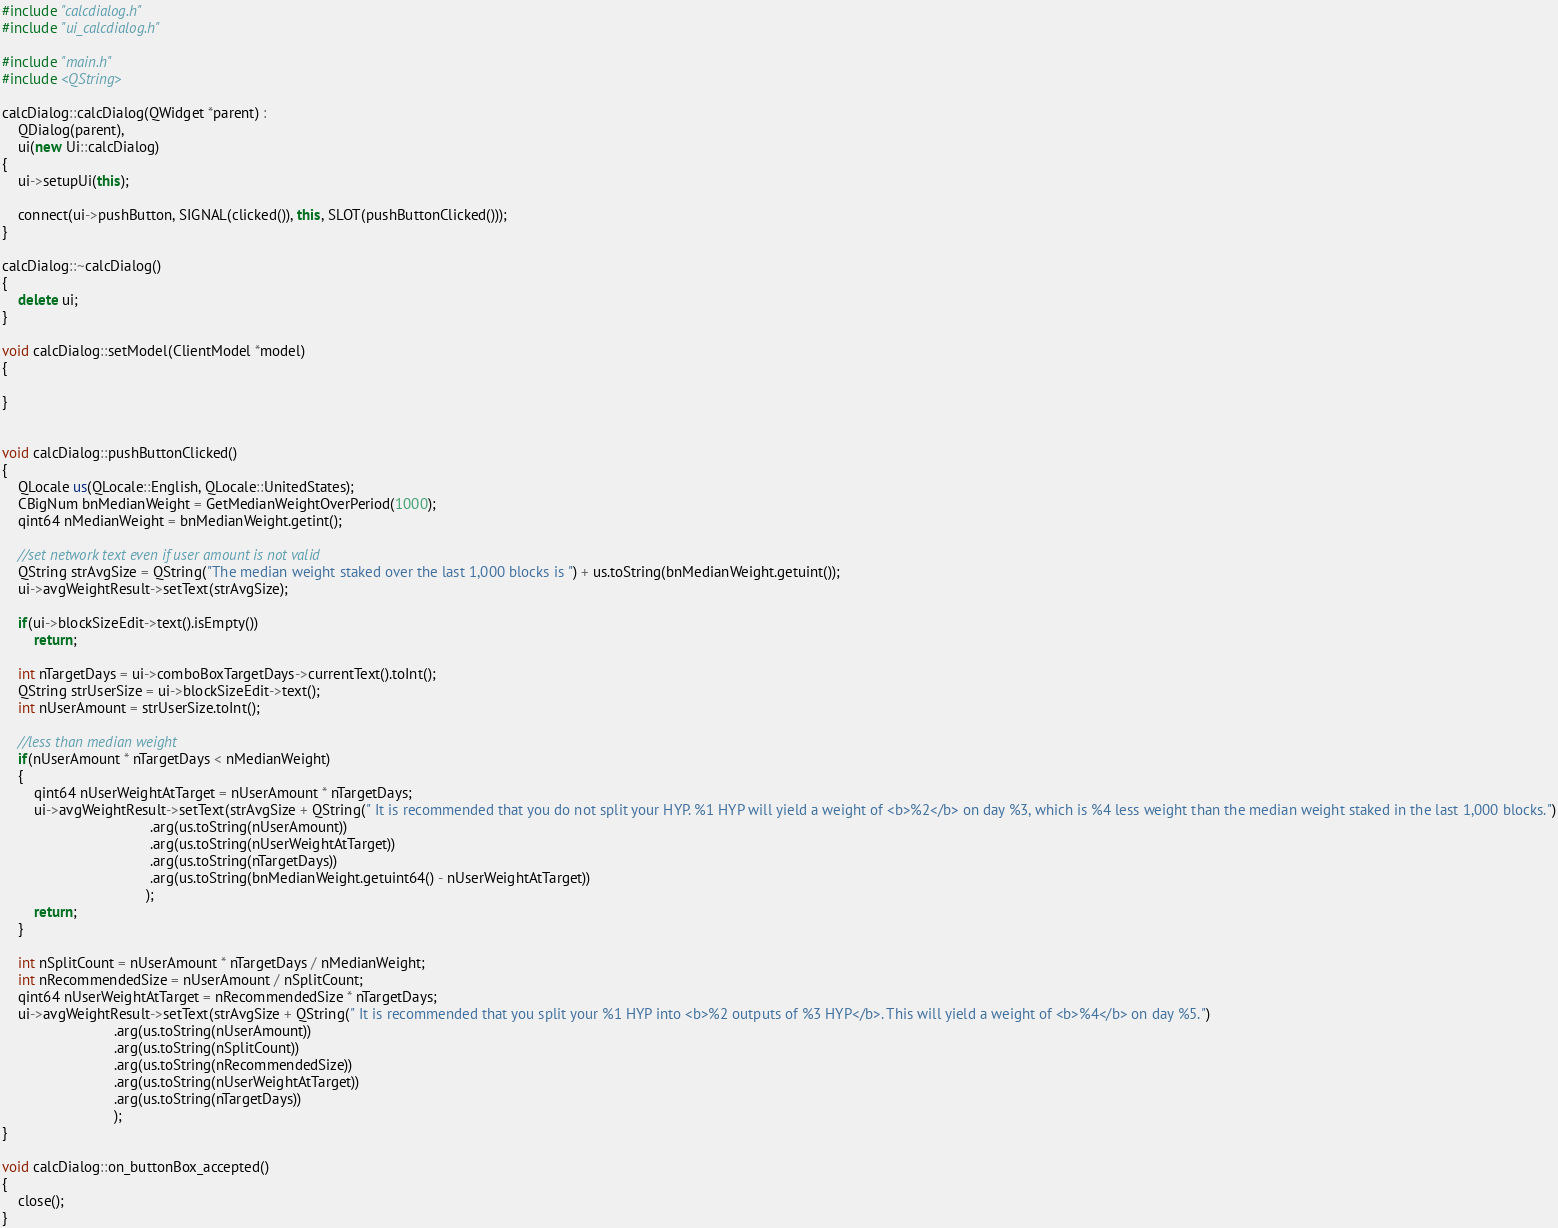Convert code to text. <code><loc_0><loc_0><loc_500><loc_500><_C++_>#include "calcdialog.h"
#include "ui_calcdialog.h"

#include "main.h"
#include <QString>

calcDialog::calcDialog(QWidget *parent) :
    QDialog(parent),
    ui(new Ui::calcDialog)
{
    ui->setupUi(this);
	
	connect(ui->pushButton, SIGNAL(clicked()), this, SLOT(pushButtonClicked()));
}

calcDialog::~calcDialog()
{
    delete ui;
}

void calcDialog::setModel(ClientModel *model)
{

}


void calcDialog::pushButtonClicked()
{
    QLocale us(QLocale::English, QLocale::UnitedStates);
    CBigNum bnMedianWeight = GetMedianWeightOverPeriod(1000);
    qint64 nMedianWeight = bnMedianWeight.getint();

    //set network text even if user amount is not valid
    QString strAvgSize = QString("The median weight staked over the last 1,000 blocks is ") + us.toString(bnMedianWeight.getuint());
    ui->avgWeightResult->setText(strAvgSize);

    if(ui->blockSizeEdit->text().isEmpty())
        return;

    int nTargetDays = ui->comboBoxTargetDays->currentText().toInt();
    QString strUserSize = ui->blockSizeEdit->text();
    int nUserAmount = strUserSize.toInt();

    //less than median weight
    if(nUserAmount * nTargetDays < nMedianWeight)
    {
        qint64 nUserWeightAtTarget = nUserAmount * nTargetDays;
        ui->avgWeightResult->setText(strAvgSize + QString(" It is recommended that you do not split your HYP. %1 HYP will yield a weight of <b>%2</b> on day %3, which is %4 less weight than the median weight staked in the last 1,000 blocks.")
                                     .arg(us.toString(nUserAmount))
                                     .arg(us.toString(nUserWeightAtTarget))
                                     .arg(us.toString(nTargetDays))
                                     .arg(us.toString(bnMedianWeight.getuint64() - nUserWeightAtTarget))
                                    );
        return;
    }

    int nSplitCount = nUserAmount * nTargetDays / nMedianWeight;
    int nRecommendedSize = nUserAmount / nSplitCount;
    qint64 nUserWeightAtTarget = nRecommendedSize * nTargetDays;
    ui->avgWeightResult->setText(strAvgSize + QString(" It is recommended that you split your %1 HYP into <b>%2 outputs of %3 HYP</b>. This will yield a weight of <b>%4</b> on day %5.")
                            .arg(us.toString(nUserAmount))
                            .arg(us.toString(nSplitCount))
                            .arg(us.toString(nRecommendedSize))
                            .arg(us.toString(nUserWeightAtTarget))
                            .arg(us.toString(nTargetDays))
                            );
}

void calcDialog::on_buttonBox_accepted()
{
	close();
}
</code> 